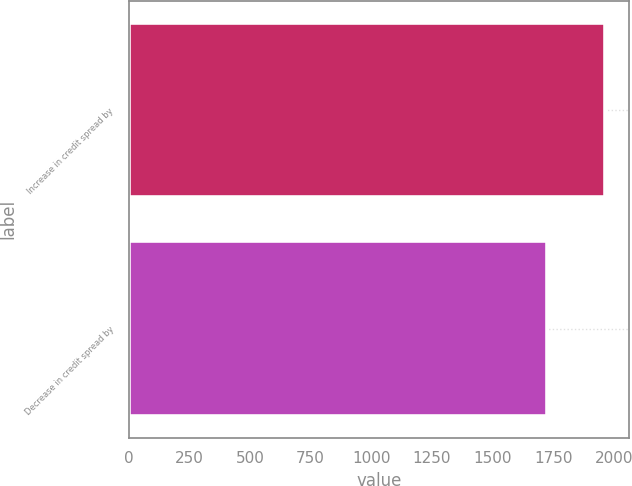<chart> <loc_0><loc_0><loc_500><loc_500><bar_chart><fcel>Increase in credit spread by<fcel>Decrease in credit spread by<nl><fcel>1964<fcel>1726<nl></chart> 